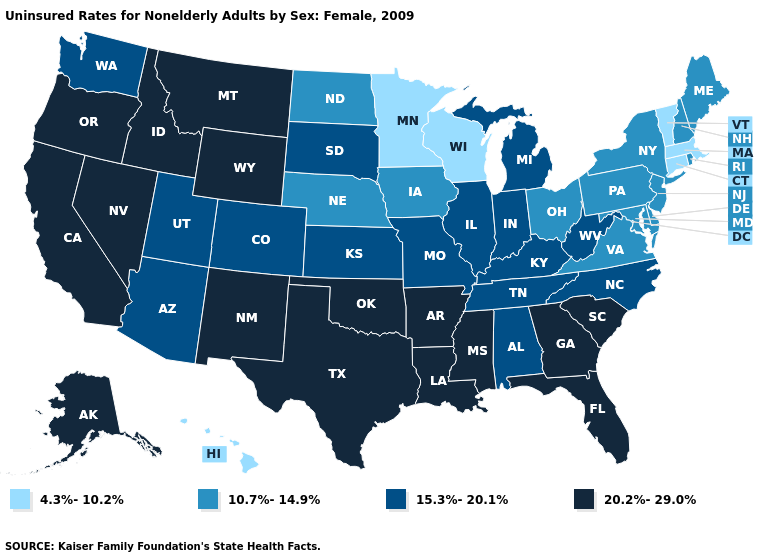Among the states that border South Carolina , does Georgia have the lowest value?
Keep it brief. No. Which states have the highest value in the USA?
Answer briefly. Alaska, Arkansas, California, Florida, Georgia, Idaho, Louisiana, Mississippi, Montana, Nevada, New Mexico, Oklahoma, Oregon, South Carolina, Texas, Wyoming. What is the value of Vermont?
Be succinct. 4.3%-10.2%. What is the highest value in the South ?
Keep it brief. 20.2%-29.0%. Name the states that have a value in the range 20.2%-29.0%?
Short answer required. Alaska, Arkansas, California, Florida, Georgia, Idaho, Louisiana, Mississippi, Montana, Nevada, New Mexico, Oklahoma, Oregon, South Carolina, Texas, Wyoming. Which states have the highest value in the USA?
Answer briefly. Alaska, Arkansas, California, Florida, Georgia, Idaho, Louisiana, Mississippi, Montana, Nevada, New Mexico, Oklahoma, Oregon, South Carolina, Texas, Wyoming. Does South Carolina have the highest value in the South?
Answer briefly. Yes. Name the states that have a value in the range 15.3%-20.1%?
Write a very short answer. Alabama, Arizona, Colorado, Illinois, Indiana, Kansas, Kentucky, Michigan, Missouri, North Carolina, South Dakota, Tennessee, Utah, Washington, West Virginia. Among the states that border Arizona , does Colorado have the lowest value?
Keep it brief. Yes. Among the states that border Utah , does Colorado have the lowest value?
Quick response, please. Yes. Name the states that have a value in the range 20.2%-29.0%?
Quick response, please. Alaska, Arkansas, California, Florida, Georgia, Idaho, Louisiana, Mississippi, Montana, Nevada, New Mexico, Oklahoma, Oregon, South Carolina, Texas, Wyoming. What is the value of Washington?
Write a very short answer. 15.3%-20.1%. What is the value of Maine?
Be succinct. 10.7%-14.9%. Which states have the lowest value in the South?
Give a very brief answer. Delaware, Maryland, Virginia. What is the value of Utah?
Quick response, please. 15.3%-20.1%. 